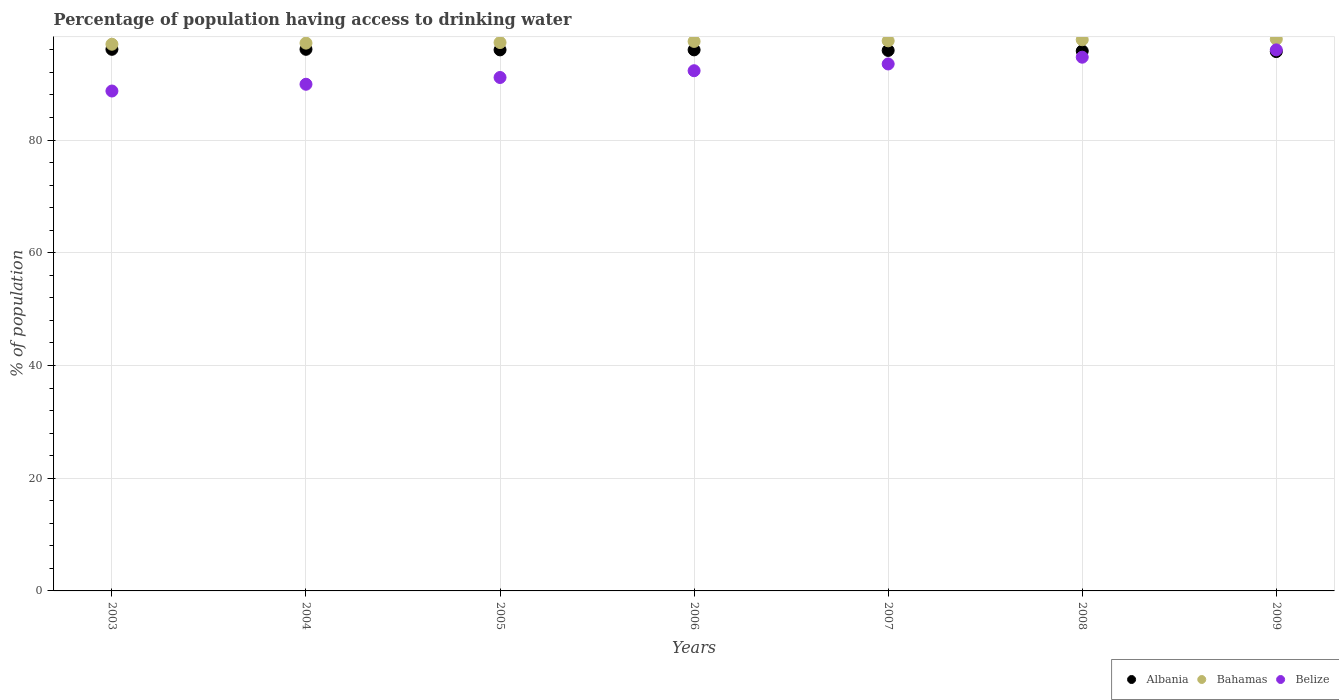What is the percentage of population having access to drinking water in Bahamas in 2007?
Your answer should be very brief. 97.6. Across all years, what is the maximum percentage of population having access to drinking water in Belize?
Ensure brevity in your answer.  96. Across all years, what is the minimum percentage of population having access to drinking water in Albania?
Make the answer very short. 95.7. What is the total percentage of population having access to drinking water in Bahamas in the graph?
Make the answer very short. 682.3. What is the difference between the percentage of population having access to drinking water in Belize in 2005 and that in 2009?
Offer a very short reply. -4.9. What is the difference between the percentage of population having access to drinking water in Albania in 2004 and the percentage of population having access to drinking water in Bahamas in 2005?
Your answer should be compact. -1.2. What is the average percentage of population having access to drinking water in Albania per year?
Give a very brief answer. 95.94. In the year 2006, what is the difference between the percentage of population having access to drinking water in Belize and percentage of population having access to drinking water in Albania?
Provide a succinct answer. -3.7. In how many years, is the percentage of population having access to drinking water in Albania greater than 64 %?
Your answer should be compact. 7. What is the ratio of the percentage of population having access to drinking water in Bahamas in 2006 to that in 2009?
Ensure brevity in your answer.  1. Is the percentage of population having access to drinking water in Bahamas in 2003 less than that in 2008?
Provide a short and direct response. Yes. What is the difference between the highest and the second highest percentage of population having access to drinking water in Belize?
Make the answer very short. 1.3. What is the difference between the highest and the lowest percentage of population having access to drinking water in Bahamas?
Your response must be concise. 0.9. In how many years, is the percentage of population having access to drinking water in Albania greater than the average percentage of population having access to drinking water in Albania taken over all years?
Your response must be concise. 4. Is it the case that in every year, the sum of the percentage of population having access to drinking water in Belize and percentage of population having access to drinking water in Bahamas  is greater than the percentage of population having access to drinking water in Albania?
Give a very brief answer. Yes. Is the percentage of population having access to drinking water in Belize strictly less than the percentage of population having access to drinking water in Bahamas over the years?
Provide a succinct answer. Yes. How many years are there in the graph?
Your response must be concise. 7. What is the difference between two consecutive major ticks on the Y-axis?
Keep it short and to the point. 20. Are the values on the major ticks of Y-axis written in scientific E-notation?
Provide a short and direct response. No. What is the title of the graph?
Ensure brevity in your answer.  Percentage of population having access to drinking water. What is the label or title of the Y-axis?
Provide a succinct answer. % of population. What is the % of population of Albania in 2003?
Your answer should be compact. 96.1. What is the % of population of Bahamas in 2003?
Your answer should be compact. 97. What is the % of population in Belize in 2003?
Offer a terse response. 88.7. What is the % of population in Albania in 2004?
Provide a succinct answer. 96.1. What is the % of population in Bahamas in 2004?
Ensure brevity in your answer.  97.2. What is the % of population of Belize in 2004?
Your answer should be compact. 89.9. What is the % of population of Albania in 2005?
Your response must be concise. 96. What is the % of population in Bahamas in 2005?
Give a very brief answer. 97.3. What is the % of population in Belize in 2005?
Provide a short and direct response. 91.1. What is the % of population of Albania in 2006?
Keep it short and to the point. 96. What is the % of population in Bahamas in 2006?
Keep it short and to the point. 97.5. What is the % of population of Belize in 2006?
Your answer should be very brief. 92.3. What is the % of population of Albania in 2007?
Offer a very short reply. 95.9. What is the % of population of Bahamas in 2007?
Your answer should be very brief. 97.6. What is the % of population of Belize in 2007?
Keep it short and to the point. 93.5. What is the % of population of Albania in 2008?
Provide a short and direct response. 95.8. What is the % of population in Bahamas in 2008?
Provide a succinct answer. 97.8. What is the % of population of Belize in 2008?
Offer a terse response. 94.7. What is the % of population in Albania in 2009?
Your response must be concise. 95.7. What is the % of population of Bahamas in 2009?
Ensure brevity in your answer.  97.9. What is the % of population of Belize in 2009?
Offer a very short reply. 96. Across all years, what is the maximum % of population of Albania?
Your answer should be very brief. 96.1. Across all years, what is the maximum % of population of Bahamas?
Offer a terse response. 97.9. Across all years, what is the maximum % of population in Belize?
Ensure brevity in your answer.  96. Across all years, what is the minimum % of population in Albania?
Your answer should be very brief. 95.7. Across all years, what is the minimum % of population in Bahamas?
Ensure brevity in your answer.  97. Across all years, what is the minimum % of population in Belize?
Keep it short and to the point. 88.7. What is the total % of population in Albania in the graph?
Offer a very short reply. 671.6. What is the total % of population in Bahamas in the graph?
Provide a short and direct response. 682.3. What is the total % of population in Belize in the graph?
Keep it short and to the point. 646.2. What is the difference between the % of population of Bahamas in 2003 and that in 2004?
Keep it short and to the point. -0.2. What is the difference between the % of population in Belize in 2003 and that in 2004?
Your response must be concise. -1.2. What is the difference between the % of population of Albania in 2003 and that in 2005?
Your response must be concise. 0.1. What is the difference between the % of population in Bahamas in 2003 and that in 2005?
Give a very brief answer. -0.3. What is the difference between the % of population of Belize in 2003 and that in 2005?
Make the answer very short. -2.4. What is the difference between the % of population of Bahamas in 2003 and that in 2006?
Give a very brief answer. -0.5. What is the difference between the % of population in Belize in 2003 and that in 2006?
Make the answer very short. -3.6. What is the difference between the % of population of Bahamas in 2003 and that in 2008?
Give a very brief answer. -0.8. What is the difference between the % of population of Bahamas in 2003 and that in 2009?
Provide a short and direct response. -0.9. What is the difference between the % of population in Belize in 2003 and that in 2009?
Your response must be concise. -7.3. What is the difference between the % of population of Bahamas in 2004 and that in 2006?
Keep it short and to the point. -0.3. What is the difference between the % of population of Belize in 2004 and that in 2006?
Provide a succinct answer. -2.4. What is the difference between the % of population in Bahamas in 2004 and that in 2007?
Your response must be concise. -0.4. What is the difference between the % of population of Belize in 2004 and that in 2007?
Your answer should be very brief. -3.6. What is the difference between the % of population in Albania in 2004 and that in 2008?
Keep it short and to the point. 0.3. What is the difference between the % of population in Bahamas in 2004 and that in 2008?
Ensure brevity in your answer.  -0.6. What is the difference between the % of population in Albania in 2004 and that in 2009?
Keep it short and to the point. 0.4. What is the difference between the % of population of Bahamas in 2004 and that in 2009?
Provide a succinct answer. -0.7. What is the difference between the % of population in Belize in 2004 and that in 2009?
Provide a short and direct response. -6.1. What is the difference between the % of population of Albania in 2005 and that in 2006?
Your answer should be very brief. 0. What is the difference between the % of population in Bahamas in 2005 and that in 2006?
Your answer should be very brief. -0.2. What is the difference between the % of population of Bahamas in 2005 and that in 2007?
Give a very brief answer. -0.3. What is the difference between the % of population in Albania in 2005 and that in 2008?
Your answer should be compact. 0.2. What is the difference between the % of population of Bahamas in 2005 and that in 2009?
Provide a succinct answer. -0.6. What is the difference between the % of population of Bahamas in 2006 and that in 2007?
Provide a short and direct response. -0.1. What is the difference between the % of population of Belize in 2006 and that in 2007?
Provide a short and direct response. -1.2. What is the difference between the % of population of Bahamas in 2006 and that in 2008?
Make the answer very short. -0.3. What is the difference between the % of population in Albania in 2006 and that in 2009?
Provide a succinct answer. 0.3. What is the difference between the % of population in Belize in 2006 and that in 2009?
Provide a succinct answer. -3.7. What is the difference between the % of population in Bahamas in 2007 and that in 2008?
Provide a short and direct response. -0.2. What is the difference between the % of population of Belize in 2007 and that in 2008?
Keep it short and to the point. -1.2. What is the difference between the % of population of Bahamas in 2007 and that in 2009?
Ensure brevity in your answer.  -0.3. What is the difference between the % of population in Belize in 2007 and that in 2009?
Make the answer very short. -2.5. What is the difference between the % of population in Albania in 2008 and that in 2009?
Make the answer very short. 0.1. What is the difference between the % of population in Belize in 2008 and that in 2009?
Offer a terse response. -1.3. What is the difference between the % of population in Albania in 2003 and the % of population in Belize in 2005?
Your answer should be compact. 5. What is the difference between the % of population in Bahamas in 2003 and the % of population in Belize in 2005?
Your response must be concise. 5.9. What is the difference between the % of population of Albania in 2003 and the % of population of Belize in 2006?
Offer a very short reply. 3.8. What is the difference between the % of population in Albania in 2003 and the % of population in Bahamas in 2007?
Ensure brevity in your answer.  -1.5. What is the difference between the % of population of Albania in 2003 and the % of population of Belize in 2007?
Give a very brief answer. 2.6. What is the difference between the % of population of Bahamas in 2003 and the % of population of Belize in 2007?
Give a very brief answer. 3.5. What is the difference between the % of population in Albania in 2003 and the % of population in Belize in 2008?
Offer a terse response. 1.4. What is the difference between the % of population of Bahamas in 2003 and the % of population of Belize in 2008?
Offer a very short reply. 2.3. What is the difference between the % of population in Albania in 2003 and the % of population in Belize in 2009?
Keep it short and to the point. 0.1. What is the difference between the % of population in Bahamas in 2003 and the % of population in Belize in 2009?
Offer a very short reply. 1. What is the difference between the % of population in Albania in 2004 and the % of population in Belize in 2005?
Offer a very short reply. 5. What is the difference between the % of population in Bahamas in 2004 and the % of population in Belize in 2005?
Keep it short and to the point. 6.1. What is the difference between the % of population in Albania in 2004 and the % of population in Bahamas in 2007?
Give a very brief answer. -1.5. What is the difference between the % of population of Albania in 2004 and the % of population of Belize in 2007?
Keep it short and to the point. 2.6. What is the difference between the % of population of Bahamas in 2004 and the % of population of Belize in 2007?
Your answer should be very brief. 3.7. What is the difference between the % of population in Albania in 2004 and the % of population in Bahamas in 2008?
Offer a very short reply. -1.7. What is the difference between the % of population in Bahamas in 2004 and the % of population in Belize in 2008?
Provide a short and direct response. 2.5. What is the difference between the % of population of Albania in 2004 and the % of population of Bahamas in 2009?
Ensure brevity in your answer.  -1.8. What is the difference between the % of population in Albania in 2005 and the % of population in Bahamas in 2006?
Make the answer very short. -1.5. What is the difference between the % of population in Albania in 2005 and the % of population in Belize in 2006?
Provide a succinct answer. 3.7. What is the difference between the % of population of Bahamas in 2005 and the % of population of Belize in 2006?
Keep it short and to the point. 5. What is the difference between the % of population in Bahamas in 2005 and the % of population in Belize in 2007?
Your answer should be compact. 3.8. What is the difference between the % of population of Albania in 2005 and the % of population of Bahamas in 2008?
Your answer should be compact. -1.8. What is the difference between the % of population in Albania in 2005 and the % of population in Belize in 2008?
Provide a short and direct response. 1.3. What is the difference between the % of population of Bahamas in 2005 and the % of population of Belize in 2008?
Ensure brevity in your answer.  2.6. What is the difference between the % of population in Albania in 2006 and the % of population in Belize in 2007?
Your answer should be very brief. 2.5. What is the difference between the % of population of Bahamas in 2006 and the % of population of Belize in 2007?
Ensure brevity in your answer.  4. What is the difference between the % of population of Albania in 2006 and the % of population of Bahamas in 2008?
Ensure brevity in your answer.  -1.8. What is the difference between the % of population of Albania in 2006 and the % of population of Belize in 2008?
Keep it short and to the point. 1.3. What is the difference between the % of population of Albania in 2006 and the % of population of Belize in 2009?
Ensure brevity in your answer.  0. What is the difference between the % of population in Bahamas in 2006 and the % of population in Belize in 2009?
Offer a terse response. 1.5. What is the difference between the % of population of Albania in 2007 and the % of population of Bahamas in 2008?
Make the answer very short. -1.9. What is the difference between the % of population of Bahamas in 2007 and the % of population of Belize in 2009?
Make the answer very short. 1.6. What is the difference between the % of population of Albania in 2008 and the % of population of Bahamas in 2009?
Offer a terse response. -2.1. What is the difference between the % of population of Bahamas in 2008 and the % of population of Belize in 2009?
Provide a succinct answer. 1.8. What is the average % of population in Albania per year?
Keep it short and to the point. 95.94. What is the average % of population of Bahamas per year?
Offer a very short reply. 97.47. What is the average % of population in Belize per year?
Offer a very short reply. 92.31. In the year 2003, what is the difference between the % of population in Albania and % of population in Bahamas?
Your answer should be very brief. -0.9. In the year 2004, what is the difference between the % of population of Bahamas and % of population of Belize?
Ensure brevity in your answer.  7.3. In the year 2005, what is the difference between the % of population of Albania and % of population of Bahamas?
Your response must be concise. -1.3. In the year 2005, what is the difference between the % of population in Bahamas and % of population in Belize?
Your answer should be compact. 6.2. In the year 2006, what is the difference between the % of population in Bahamas and % of population in Belize?
Your answer should be very brief. 5.2. In the year 2007, what is the difference between the % of population of Albania and % of population of Bahamas?
Keep it short and to the point. -1.7. In the year 2007, what is the difference between the % of population of Albania and % of population of Belize?
Make the answer very short. 2.4. In the year 2008, what is the difference between the % of population of Albania and % of population of Bahamas?
Offer a very short reply. -2. In the year 2008, what is the difference between the % of population in Albania and % of population in Belize?
Provide a short and direct response. 1.1. In the year 2008, what is the difference between the % of population of Bahamas and % of population of Belize?
Your answer should be compact. 3.1. In the year 2009, what is the difference between the % of population in Albania and % of population in Belize?
Offer a very short reply. -0.3. What is the ratio of the % of population of Belize in 2003 to that in 2004?
Keep it short and to the point. 0.99. What is the ratio of the % of population in Bahamas in 2003 to that in 2005?
Offer a terse response. 1. What is the ratio of the % of population of Belize in 2003 to that in 2005?
Provide a succinct answer. 0.97. What is the ratio of the % of population in Bahamas in 2003 to that in 2006?
Your answer should be very brief. 0.99. What is the ratio of the % of population of Belize in 2003 to that in 2006?
Keep it short and to the point. 0.96. What is the ratio of the % of population of Albania in 2003 to that in 2007?
Your response must be concise. 1. What is the ratio of the % of population in Bahamas in 2003 to that in 2007?
Your answer should be very brief. 0.99. What is the ratio of the % of population of Belize in 2003 to that in 2007?
Provide a short and direct response. 0.95. What is the ratio of the % of population of Albania in 2003 to that in 2008?
Offer a very short reply. 1. What is the ratio of the % of population in Belize in 2003 to that in 2008?
Offer a very short reply. 0.94. What is the ratio of the % of population in Albania in 2003 to that in 2009?
Offer a very short reply. 1. What is the ratio of the % of population in Bahamas in 2003 to that in 2009?
Ensure brevity in your answer.  0.99. What is the ratio of the % of population of Belize in 2003 to that in 2009?
Offer a very short reply. 0.92. What is the ratio of the % of population of Albania in 2004 to that in 2005?
Make the answer very short. 1. What is the ratio of the % of population in Bahamas in 2004 to that in 2005?
Make the answer very short. 1. What is the ratio of the % of population in Albania in 2004 to that in 2006?
Your answer should be compact. 1. What is the ratio of the % of population of Bahamas in 2004 to that in 2006?
Make the answer very short. 1. What is the ratio of the % of population in Belize in 2004 to that in 2006?
Your answer should be very brief. 0.97. What is the ratio of the % of population in Belize in 2004 to that in 2007?
Make the answer very short. 0.96. What is the ratio of the % of population of Albania in 2004 to that in 2008?
Your response must be concise. 1. What is the ratio of the % of population of Bahamas in 2004 to that in 2008?
Offer a very short reply. 0.99. What is the ratio of the % of population of Belize in 2004 to that in 2008?
Your answer should be compact. 0.95. What is the ratio of the % of population in Albania in 2004 to that in 2009?
Keep it short and to the point. 1. What is the ratio of the % of population in Bahamas in 2004 to that in 2009?
Provide a succinct answer. 0.99. What is the ratio of the % of population in Belize in 2004 to that in 2009?
Your answer should be very brief. 0.94. What is the ratio of the % of population of Albania in 2005 to that in 2006?
Keep it short and to the point. 1. What is the ratio of the % of population in Bahamas in 2005 to that in 2006?
Keep it short and to the point. 1. What is the ratio of the % of population in Belize in 2005 to that in 2006?
Offer a very short reply. 0.99. What is the ratio of the % of population of Albania in 2005 to that in 2007?
Keep it short and to the point. 1. What is the ratio of the % of population of Belize in 2005 to that in 2007?
Make the answer very short. 0.97. What is the ratio of the % of population in Albania in 2005 to that in 2008?
Your answer should be compact. 1. What is the ratio of the % of population in Albania in 2005 to that in 2009?
Give a very brief answer. 1. What is the ratio of the % of population in Belize in 2005 to that in 2009?
Your answer should be compact. 0.95. What is the ratio of the % of population in Albania in 2006 to that in 2007?
Offer a very short reply. 1. What is the ratio of the % of population of Bahamas in 2006 to that in 2007?
Provide a short and direct response. 1. What is the ratio of the % of population in Belize in 2006 to that in 2007?
Offer a very short reply. 0.99. What is the ratio of the % of population in Belize in 2006 to that in 2008?
Keep it short and to the point. 0.97. What is the ratio of the % of population in Bahamas in 2006 to that in 2009?
Offer a terse response. 1. What is the ratio of the % of population in Belize in 2006 to that in 2009?
Give a very brief answer. 0.96. What is the ratio of the % of population in Albania in 2007 to that in 2008?
Make the answer very short. 1. What is the ratio of the % of population in Bahamas in 2007 to that in 2008?
Give a very brief answer. 1. What is the ratio of the % of population in Belize in 2007 to that in 2008?
Offer a terse response. 0.99. What is the ratio of the % of population in Bahamas in 2007 to that in 2009?
Your answer should be very brief. 1. What is the ratio of the % of population of Belize in 2008 to that in 2009?
Give a very brief answer. 0.99. What is the difference between the highest and the second highest % of population in Albania?
Offer a terse response. 0. What is the difference between the highest and the second highest % of population of Belize?
Your response must be concise. 1.3. What is the difference between the highest and the lowest % of population of Albania?
Provide a short and direct response. 0.4. 